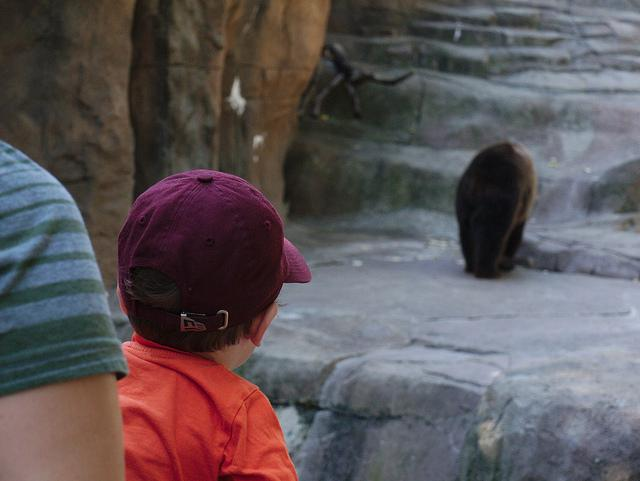Where is the boy visiting? zoo 